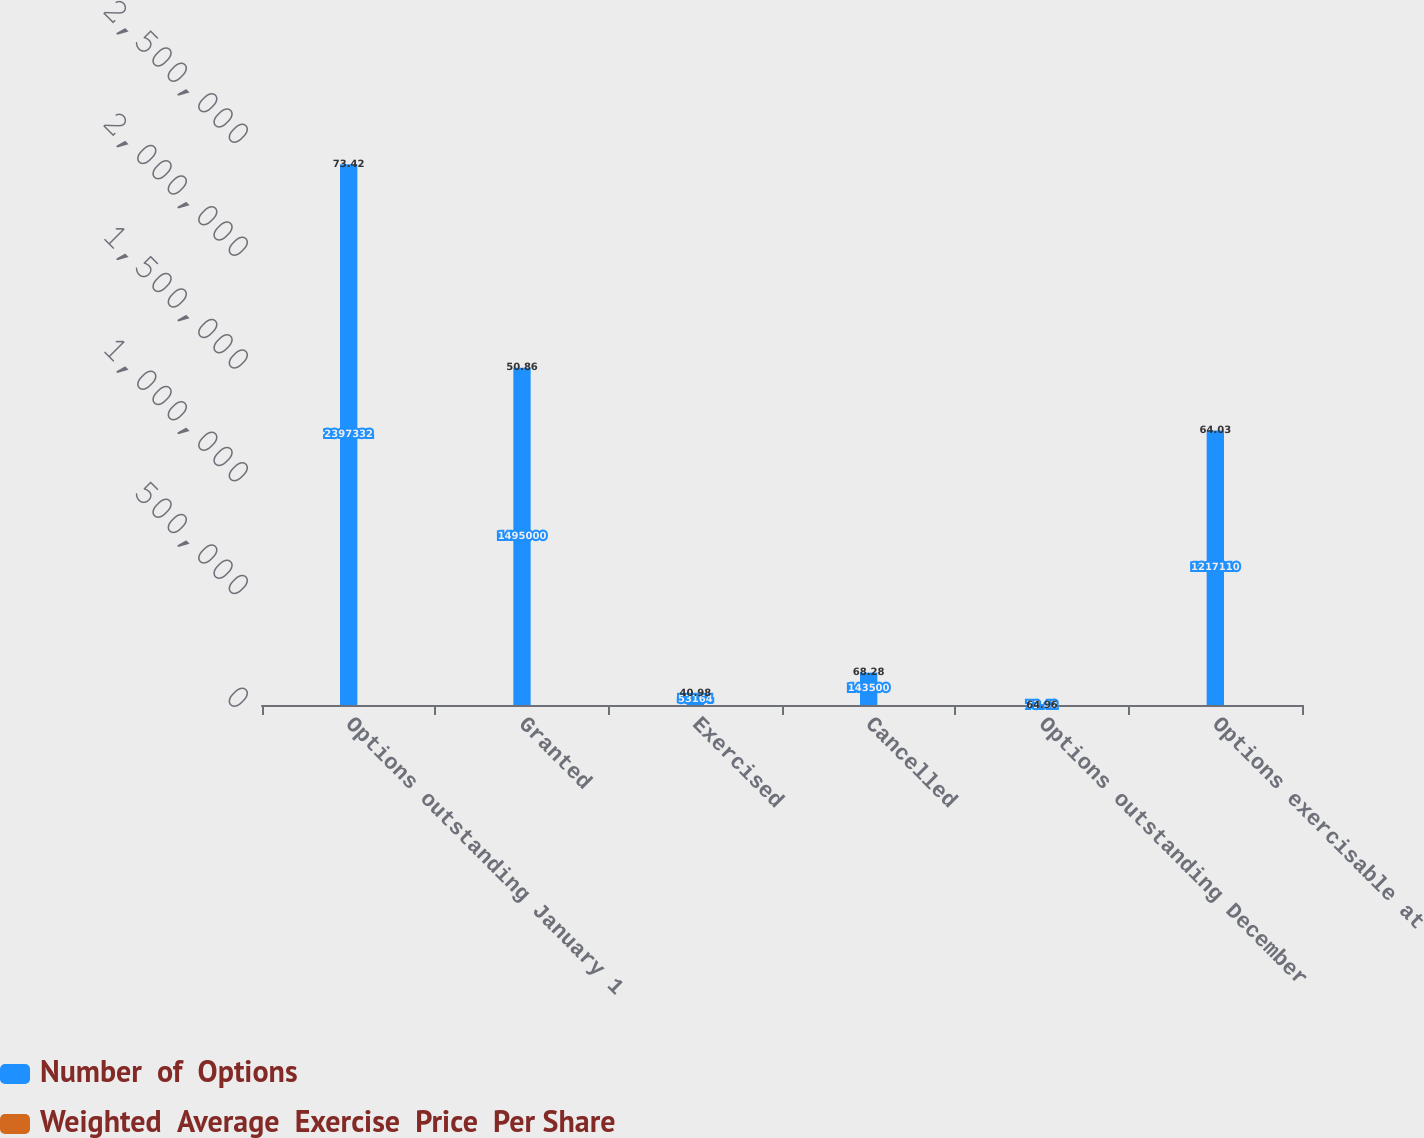<chart> <loc_0><loc_0><loc_500><loc_500><stacked_bar_chart><ecel><fcel>Options outstanding January 1<fcel>Granted<fcel>Exercised<fcel>Cancelled<fcel>Options outstanding December<fcel>Options exercisable at<nl><fcel>Number  of  Options<fcel>2.39733e+06<fcel>1.495e+06<fcel>53164<fcel>143500<fcel>73.42<fcel>1.21711e+06<nl><fcel>Weighted  Average  Exercise  Price  Per Share<fcel>73.42<fcel>50.86<fcel>40.98<fcel>68.28<fcel>64.96<fcel>64.03<nl></chart> 